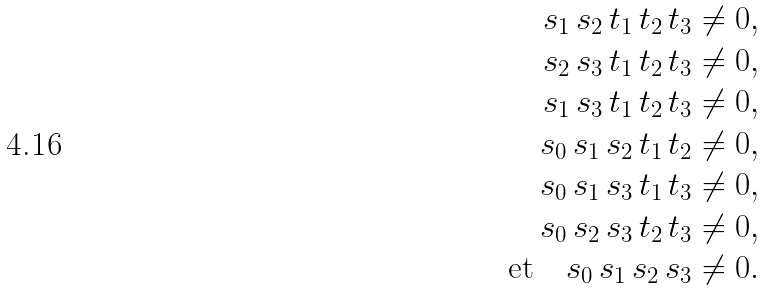<formula> <loc_0><loc_0><loc_500><loc_500>s _ { 1 } \, s _ { 2 } \, t _ { 1 } \, t _ { 2 } \, t _ { 3 } & \neq 0 , \\ s _ { 2 } \, s _ { 3 } \, t _ { 1 } \, t _ { 2 } \, t _ { 3 } & \neq 0 , \\ s _ { 1 } \, s _ { 3 } \, t _ { 1 } \, t _ { 2 } \, t _ { 3 } & \neq 0 , \\ s _ { 0 } \, s _ { 1 } \, s _ { 2 } \, t _ { 1 } \, t _ { 2 } & \neq 0 , \\ s _ { 0 } \, s _ { 1 } \, s _ { 3 } \, t _ { 1 } \, t _ { 3 } & \neq 0 , \\ s _ { 0 } \, s _ { 2 } \, s _ { 3 } \, t _ { 2 } \, t _ { 3 } & \neq 0 , \\ \text {et} \quad s _ { 0 } \, s _ { 1 } \, s _ { 2 } \, s _ { 3 } & \neq 0 .</formula> 